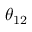Convert formula to latex. <formula><loc_0><loc_0><loc_500><loc_500>\theta _ { 1 2 }</formula> 